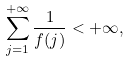Convert formula to latex. <formula><loc_0><loc_0><loc_500><loc_500>\sum _ { j = 1 } ^ { + \infty } \frac { 1 } { f ( j ) } < + \infty ,</formula> 